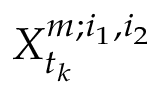Convert formula to latex. <formula><loc_0><loc_0><loc_500><loc_500>X _ { t _ { k } } ^ { m ; i _ { 1 } , i _ { 2 } }</formula> 